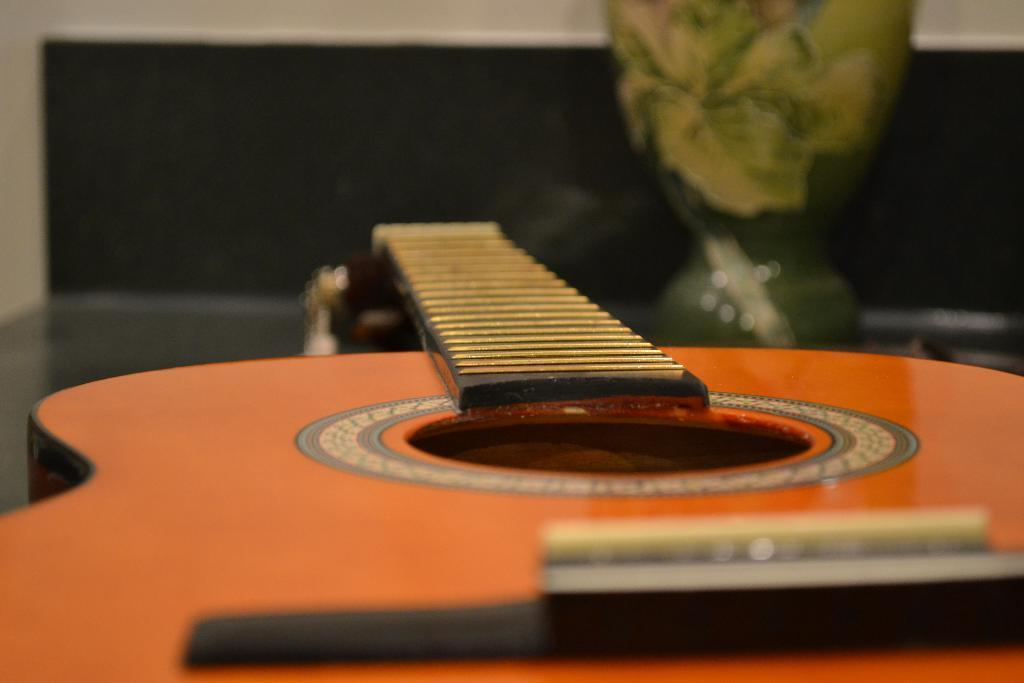What musical instrument is on the table in the image? There is a guitar on the table in the image. What else can be seen on the table besides the guitar? There are other objects on the table. What type of class is being held in the image? There is no class or indication of a class being held in the image. 